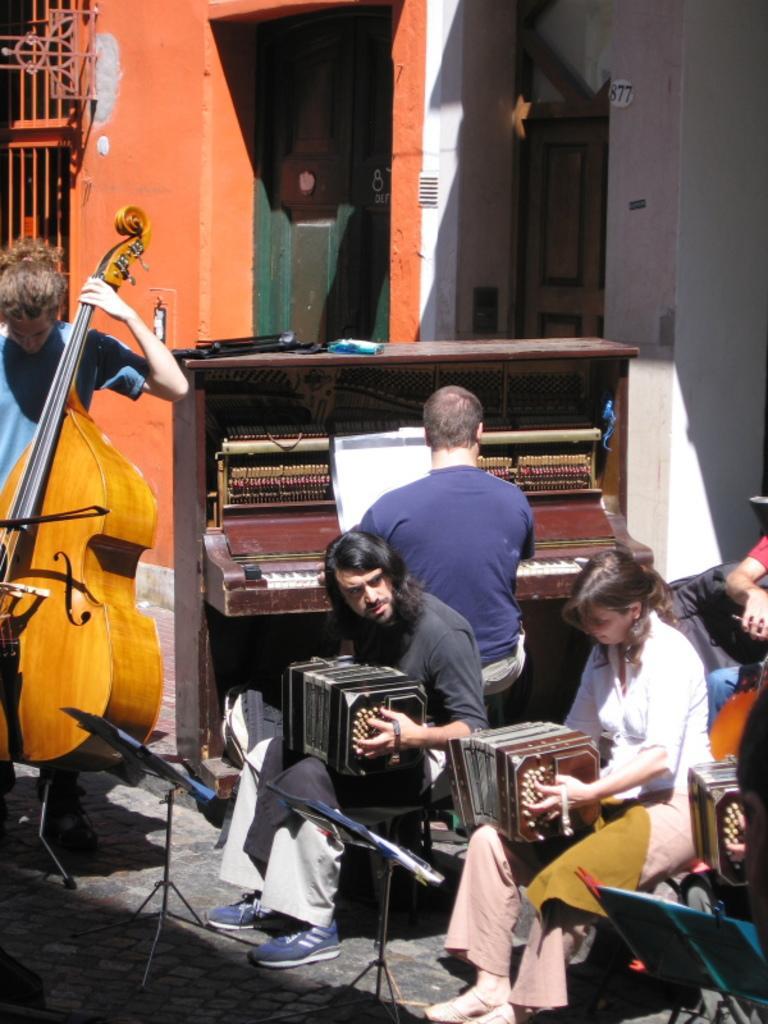Describe this image in one or two sentences. In this picture there are few musicians. The man to the left corner is playing cello. The man beside him is playing piano. The woman to the right corner and the man beside her are playing accordions. There are book holders in front of them. In the background there are houses. 